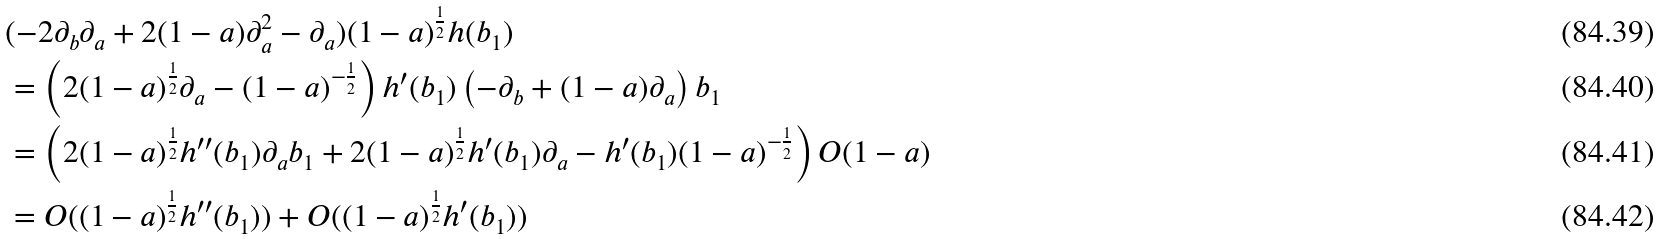Convert formula to latex. <formula><loc_0><loc_0><loc_500><loc_500>& ( - 2 \partial _ { b } \partial _ { a } + 2 ( 1 - a ) \partial _ { a } ^ { 2 } - \partial _ { a } ) ( 1 - a ) ^ { \frac { 1 } { 2 } } h ( b _ { 1 } ) \\ & = \left ( 2 ( 1 - a ) ^ { \frac { 1 } { 2 } } \partial _ { a } - ( 1 - a ) ^ { - \frac { 1 } { 2 } } \right ) h ^ { \prime } ( b _ { 1 } ) \left ( - \partial _ { b } + ( 1 - a ) \partial _ { a } \right ) b _ { 1 } \\ & = \left ( 2 ( 1 - a ) ^ { \frac { 1 } { 2 } } h ^ { \prime \prime } ( b _ { 1 } ) \partial _ { a } b _ { 1 } + 2 ( 1 - a ) ^ { \frac { 1 } { 2 } } h ^ { \prime } ( b _ { 1 } ) \partial _ { a } - h ^ { \prime } ( b _ { 1 } ) ( 1 - a ) ^ { - \frac { 1 } { 2 } } \right ) O ( 1 - a ) \\ & = O ( ( 1 - a ) ^ { \frac { 1 } { 2 } } h ^ { \prime \prime } ( b _ { 1 } ) ) + O ( ( 1 - a ) ^ { \frac { 1 } { 2 } } h ^ { \prime } ( b _ { 1 } ) )</formula> 